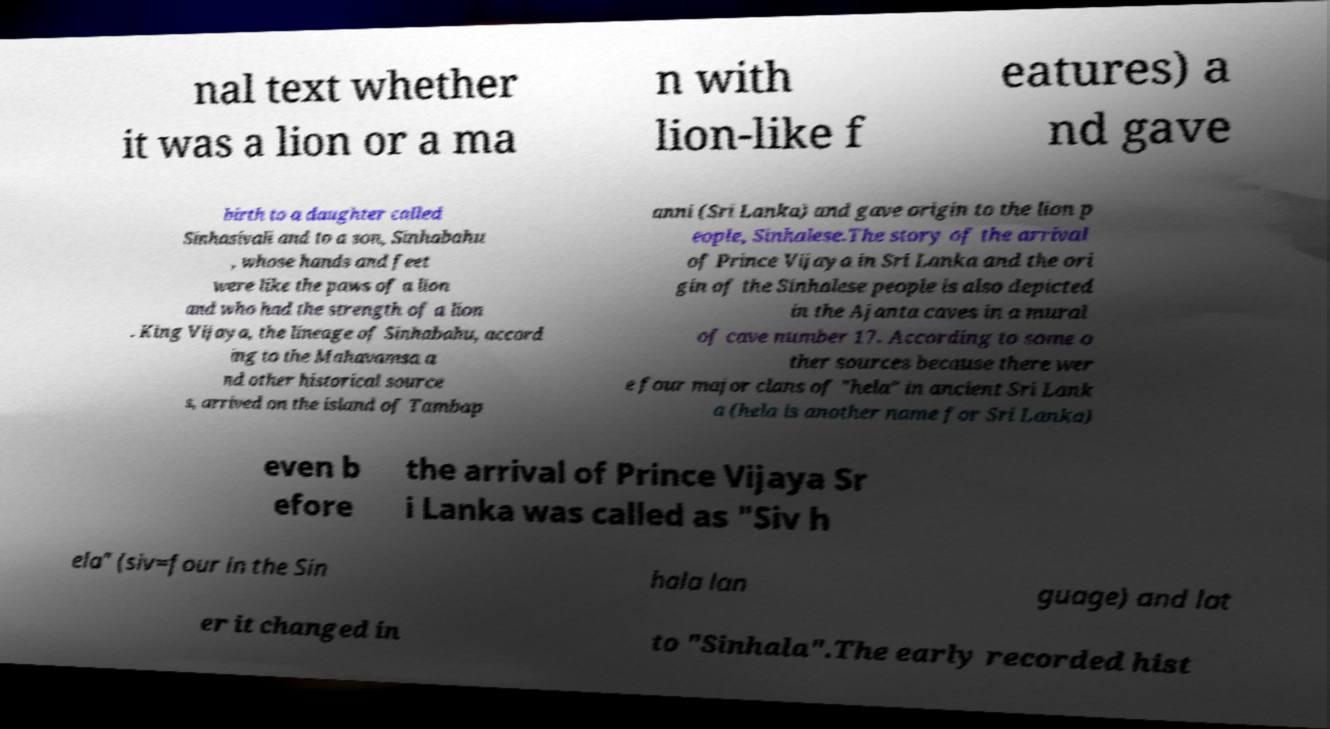Can you accurately transcribe the text from the provided image for me? nal text whether it was a lion or a ma n with lion-like f eatures) a nd gave birth to a daughter called Sinhasivali and to a son, Sinhabahu , whose hands and feet were like the paws of a lion and who had the strength of a lion . King Vijaya, the lineage of Sinhabahu, accord ing to the Mahavamsa a nd other historical source s, arrived on the island of Tambap anni (Sri Lanka) and gave origin to the lion p eople, Sinhalese.The story of the arrival of Prince Vijaya in Sri Lanka and the ori gin of the Sinhalese people is also depicted in the Ajanta caves in a mural of cave number 17. According to some o ther sources because there wer e four major clans of "hela" in ancient Sri Lank a (hela is another name for Sri Lanka) even b efore the arrival of Prince Vijaya Sr i Lanka was called as "Siv h ela" (siv=four in the Sin hala lan guage) and lat er it changed in to "Sinhala".The early recorded hist 